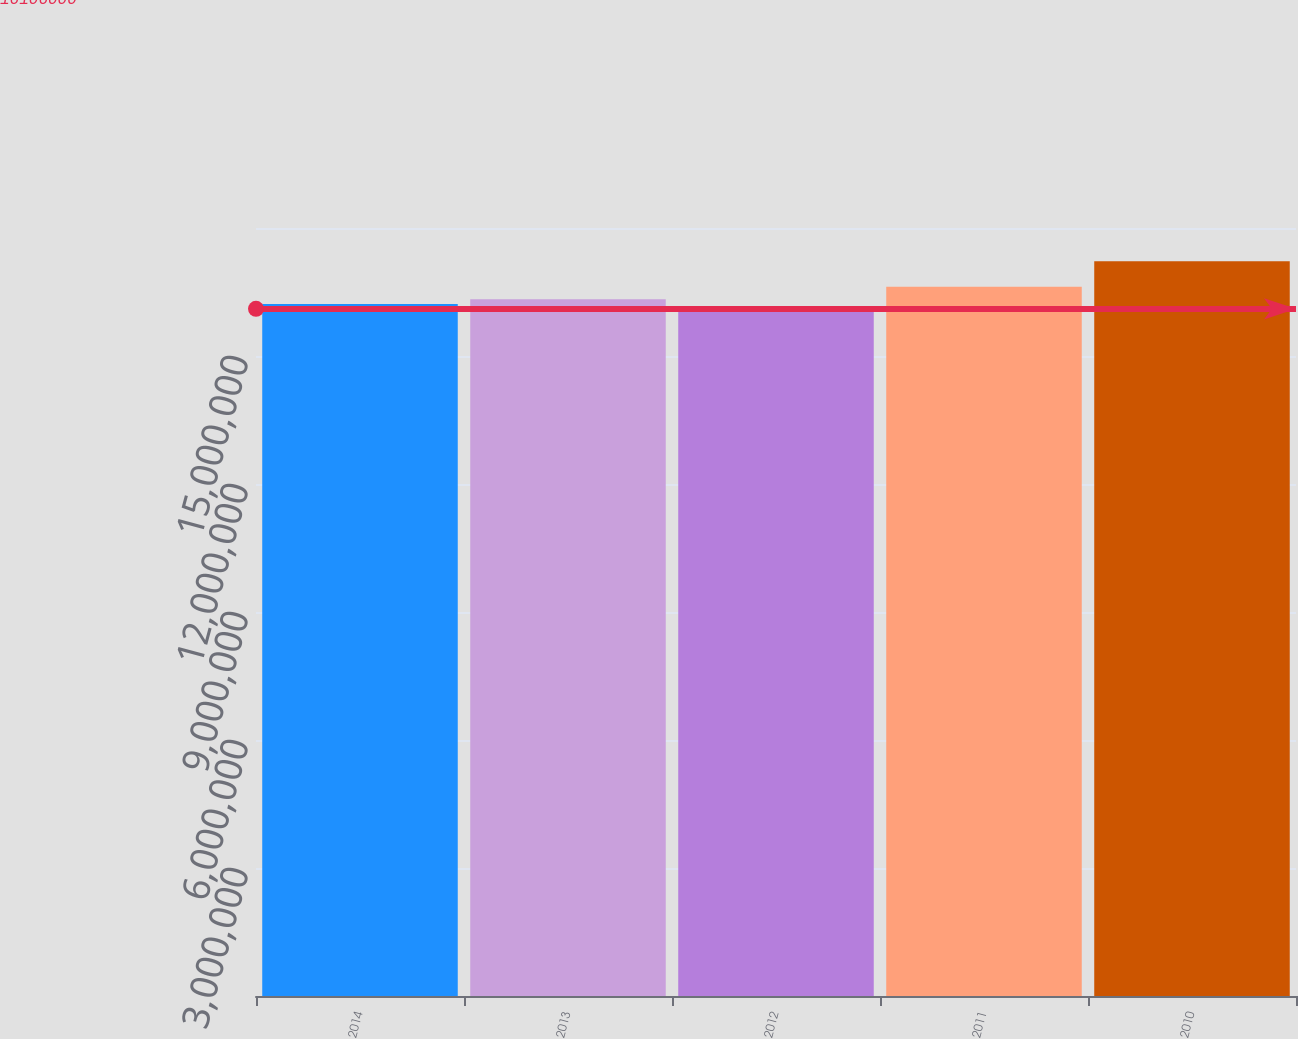Convert chart to OTSL. <chart><loc_0><loc_0><loc_500><loc_500><bar_chart><fcel>2014<fcel>2013<fcel>2012<fcel>2011<fcel>2010<nl><fcel>1.62173e+07<fcel>1.63286e+07<fcel>1.6106e+07<fcel>1.6623e+07<fcel>1.7219e+07<nl></chart> 